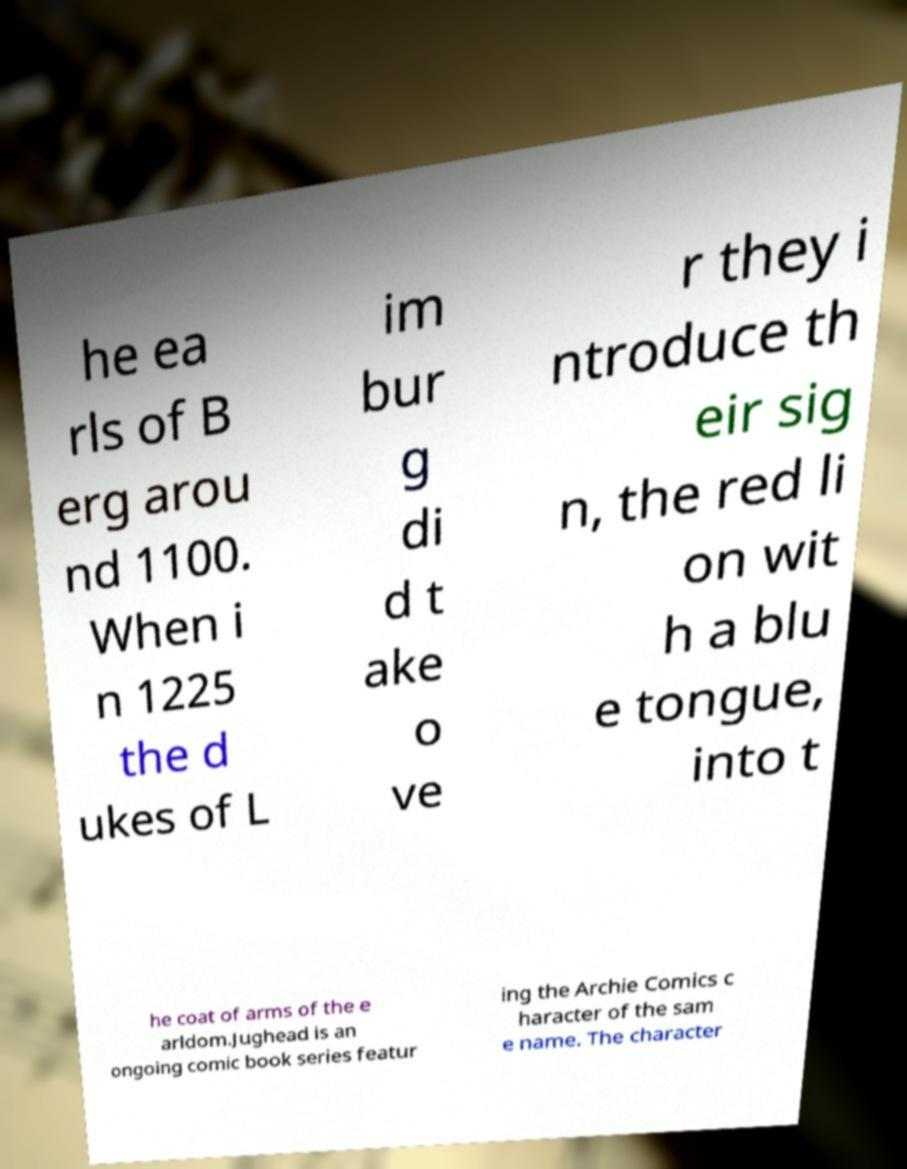What messages or text are displayed in this image? I need them in a readable, typed format. he ea rls of B erg arou nd 1100. When i n 1225 the d ukes of L im bur g di d t ake o ve r they i ntroduce th eir sig n, the red li on wit h a blu e tongue, into t he coat of arms of the e arldom.Jughead is an ongoing comic book series featur ing the Archie Comics c haracter of the sam e name. The character 